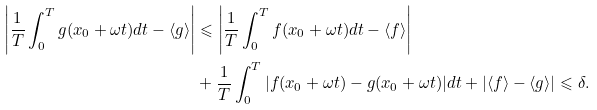Convert formula to latex. <formula><loc_0><loc_0><loc_500><loc_500>\left | \frac { 1 } { T } \int _ { 0 } ^ { T } g ( x _ { 0 } + \omega t ) d t - \langle g \rangle \right | & \leqslant \left | \frac { 1 } { T } \int _ { 0 } ^ { T } f ( x _ { 0 } + \omega t ) d t - \langle f \rangle \right | \\ & + \frac { 1 } { T } \int _ { 0 } ^ { T } | f ( x _ { 0 } + \omega t ) - g ( x _ { 0 } + \omega t ) | d t + | \langle f \rangle - \langle g \rangle | \leqslant \delta .</formula> 